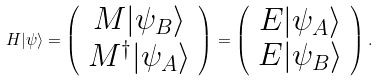<formula> <loc_0><loc_0><loc_500><loc_500>H | \psi \rangle = \left ( \begin{array} { c } M | \psi _ { B } \rangle \\ M ^ { \dagger } | \psi _ { A } \rangle \end{array} \right ) = \left ( \begin{array} { c } E | \psi _ { A } \rangle \\ E | \psi _ { B } \rangle \end{array} \right ) .</formula> 